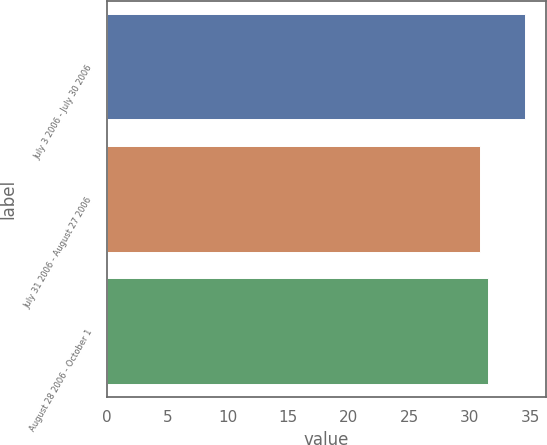<chart> <loc_0><loc_0><loc_500><loc_500><bar_chart><fcel>July 3 2006 - July 30 2006<fcel>July 31 2006 - August 27 2006<fcel>August 28 2006 - October 1<nl><fcel>34.54<fcel>30.87<fcel>31.48<nl></chart> 